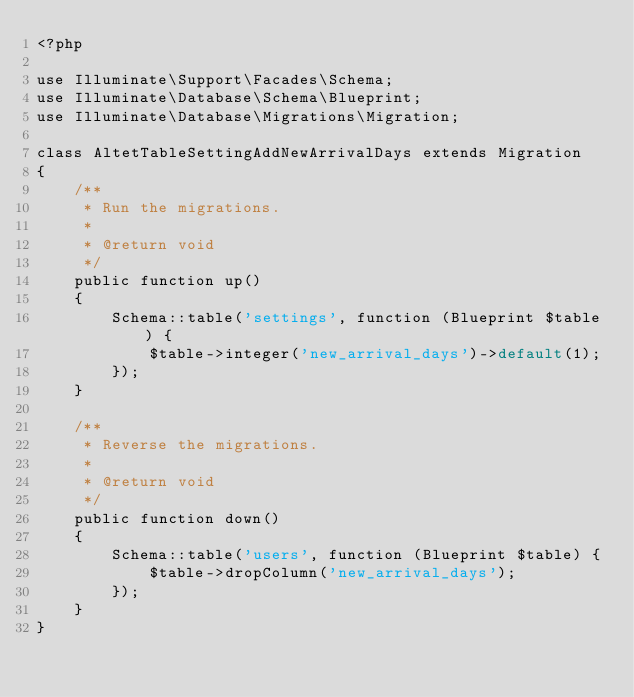Convert code to text. <code><loc_0><loc_0><loc_500><loc_500><_PHP_><?php

use Illuminate\Support\Facades\Schema;
use Illuminate\Database\Schema\Blueprint;
use Illuminate\Database\Migrations\Migration;

class AltetTableSettingAddNewArrivalDays extends Migration
{
    /**
     * Run the migrations.
     *
     * @return void
     */
    public function up()
    {
        Schema::table('settings', function (Blueprint $table) {
            $table->integer('new_arrival_days')->default(1);
        });
    }

    /**
     * Reverse the migrations.
     *
     * @return void
     */
    public function down()
    {
        Schema::table('users', function (Blueprint $table) {
            $table->dropColumn('new_arrival_days');
        });
    }
}
</code> 